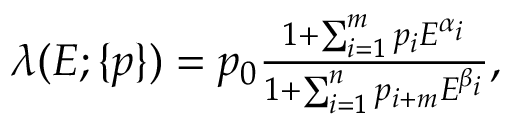Convert formula to latex. <formula><loc_0><loc_0><loc_500><loc_500>\begin{array} { r } { \lambda ( E ; \{ p \} ) = p _ { 0 } \frac { 1 + \sum _ { i = 1 } ^ { m } p _ { i } E ^ { \alpha _ { i } } } { 1 + \sum _ { i = 1 } ^ { n } p _ { i + m } E ^ { \beta _ { i } } } , } \end{array}</formula> 